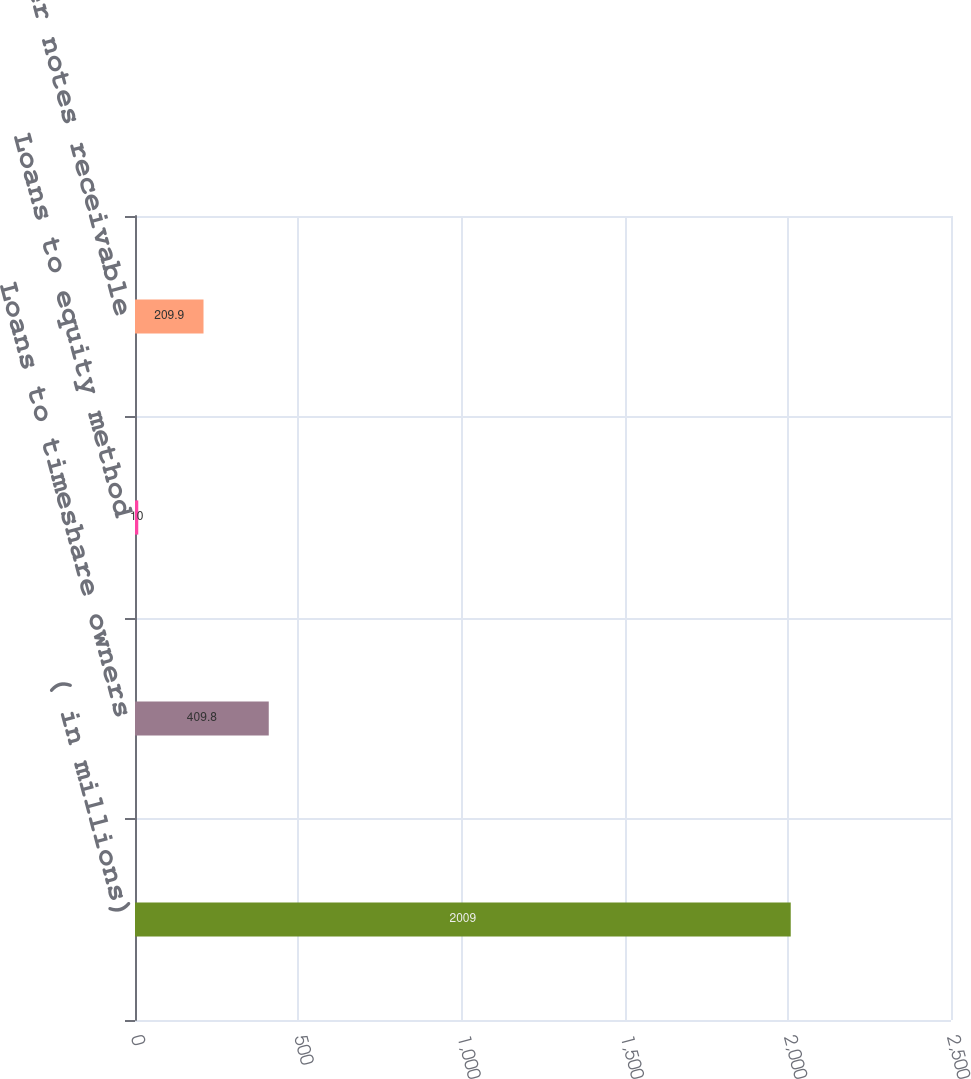Convert chart to OTSL. <chart><loc_0><loc_0><loc_500><loc_500><bar_chart><fcel>( in millions)<fcel>Loans to timeshare owners<fcel>Loans to equity method<fcel>Other notes receivable<nl><fcel>2009<fcel>409.8<fcel>10<fcel>209.9<nl></chart> 